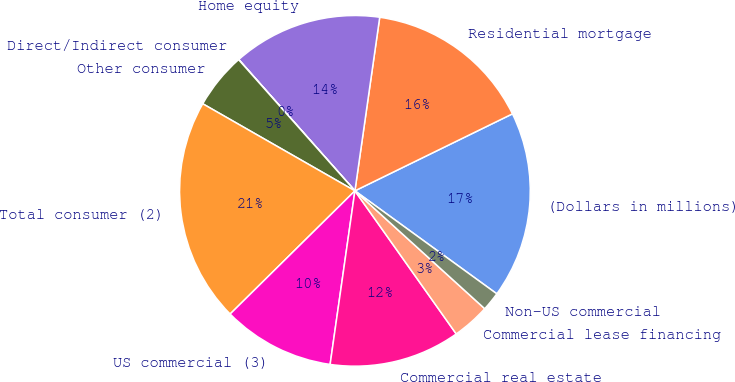<chart> <loc_0><loc_0><loc_500><loc_500><pie_chart><fcel>(Dollars in millions)<fcel>Residential mortgage<fcel>Home equity<fcel>Direct/Indirect consumer<fcel>Other consumer<fcel>Total consumer (2)<fcel>US commercial (3)<fcel>Commercial real estate<fcel>Commercial lease financing<fcel>Non-US commercial<nl><fcel>17.22%<fcel>15.5%<fcel>13.78%<fcel>0.02%<fcel>5.18%<fcel>20.66%<fcel>10.34%<fcel>12.06%<fcel>3.46%<fcel>1.74%<nl></chart> 